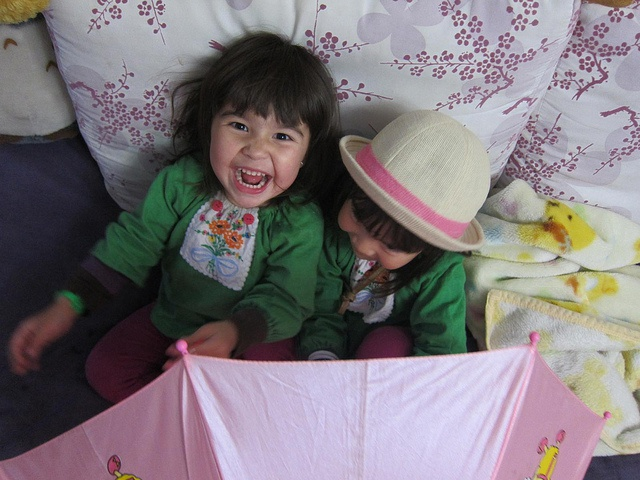Describe the objects in this image and their specific colors. I can see bed in olive, darkgray, gray, and lightgray tones, bed in olive, black, darkgray, gray, and beige tones, people in olive, black, darkgreen, and gray tones, umbrella in olive, lavender, gray, and lightpink tones, and people in olive, black, darkgray, gray, and lightgray tones in this image. 